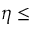<formula> <loc_0><loc_0><loc_500><loc_500>\eta \leq</formula> 